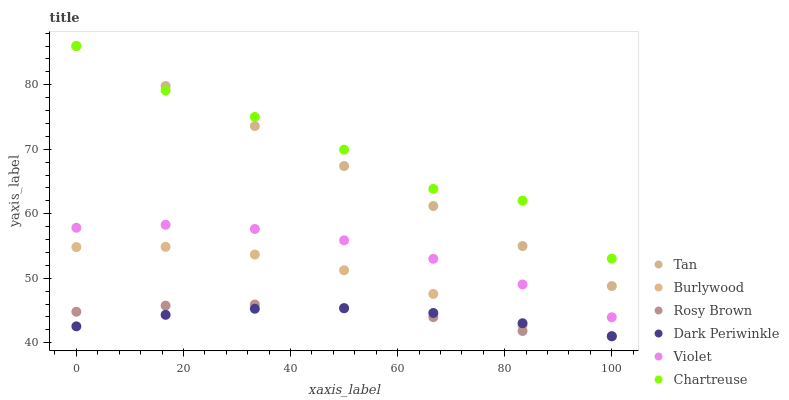Does Dark Periwinkle have the minimum area under the curve?
Answer yes or no. Yes. Does Chartreuse have the maximum area under the curve?
Answer yes or no. Yes. Does Rosy Brown have the minimum area under the curve?
Answer yes or no. No. Does Rosy Brown have the maximum area under the curve?
Answer yes or no. No. Is Tan the smoothest?
Answer yes or no. Yes. Is Chartreuse the roughest?
Answer yes or no. Yes. Is Rosy Brown the smoothest?
Answer yes or no. No. Is Rosy Brown the roughest?
Answer yes or no. No. Does Burlywood have the lowest value?
Answer yes or no. Yes. Does Chartreuse have the lowest value?
Answer yes or no. No. Does Tan have the highest value?
Answer yes or no. Yes. Does Rosy Brown have the highest value?
Answer yes or no. No. Is Burlywood less than Tan?
Answer yes or no. Yes. Is Chartreuse greater than Dark Periwinkle?
Answer yes or no. Yes. Does Rosy Brown intersect Dark Periwinkle?
Answer yes or no. Yes. Is Rosy Brown less than Dark Periwinkle?
Answer yes or no. No. Is Rosy Brown greater than Dark Periwinkle?
Answer yes or no. No. Does Burlywood intersect Tan?
Answer yes or no. No. 